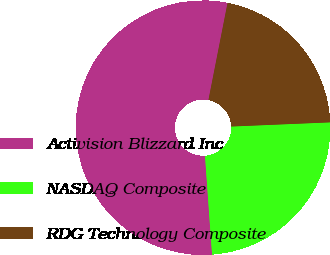Convert chart to OTSL. <chart><loc_0><loc_0><loc_500><loc_500><pie_chart><fcel>Activision Blizzard Inc<fcel>NASDAQ Composite<fcel>RDG Technology Composite<nl><fcel>54.23%<fcel>24.54%<fcel>21.24%<nl></chart> 